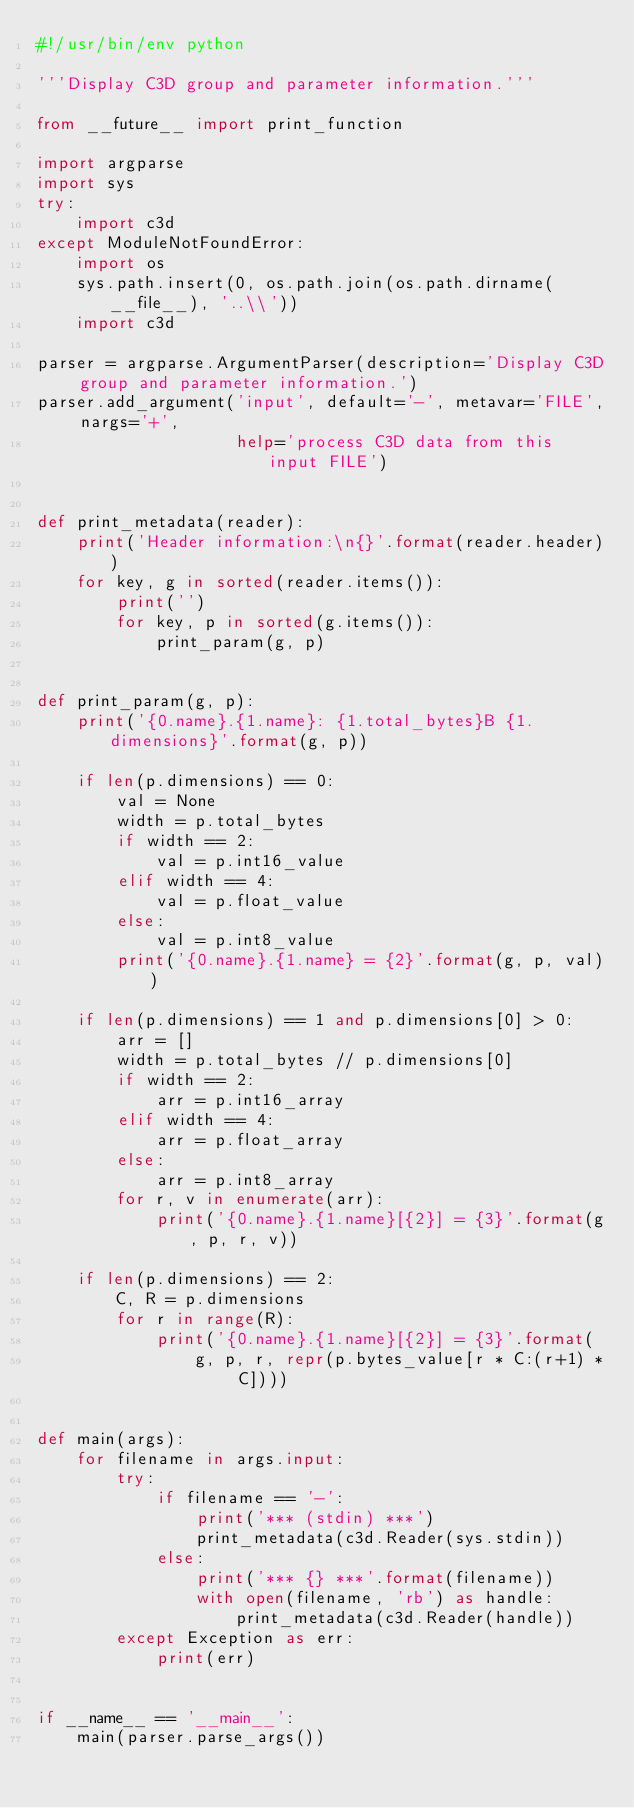Convert code to text. <code><loc_0><loc_0><loc_500><loc_500><_Python_>#!/usr/bin/env python

'''Display C3D group and parameter information.'''

from __future__ import print_function

import argparse
import sys
try:
    import c3d
except ModuleNotFoundError:
    import os
    sys.path.insert(0, os.path.join(os.path.dirname(__file__), '..\\'))
    import c3d

parser = argparse.ArgumentParser(description='Display C3D group and parameter information.')
parser.add_argument('input', default='-', metavar='FILE', nargs='+',
                    help='process C3D data from this input FILE')


def print_metadata(reader):
    print('Header information:\n{}'.format(reader.header))
    for key, g in sorted(reader.items()):
        print('')
        for key, p in sorted(g.items()):
            print_param(g, p)


def print_param(g, p):
    print('{0.name}.{1.name}: {1.total_bytes}B {1.dimensions}'.format(g, p))

    if len(p.dimensions) == 0:
        val = None
        width = p.total_bytes
        if width == 2:
            val = p.int16_value
        elif width == 4:
            val = p.float_value
        else:
            val = p.int8_value
        print('{0.name}.{1.name} = {2}'.format(g, p, val))

    if len(p.dimensions) == 1 and p.dimensions[0] > 0:
        arr = []
        width = p.total_bytes // p.dimensions[0]
        if width == 2:
            arr = p.int16_array
        elif width == 4:
            arr = p.float_array
        else:
            arr = p.int8_array
        for r, v in enumerate(arr):
            print('{0.name}.{1.name}[{2}] = {3}'.format(g, p, r, v))

    if len(p.dimensions) == 2:
        C, R = p.dimensions
        for r in range(R):
            print('{0.name}.{1.name}[{2}] = {3}'.format(
                g, p, r, repr(p.bytes_value[r * C:(r+1) * C])))


def main(args):
    for filename in args.input:
        try:
            if filename == '-':
                print('*** (stdin) ***')
                print_metadata(c3d.Reader(sys.stdin))
            else:
                print('*** {} ***'.format(filename))
                with open(filename, 'rb') as handle:
                    print_metadata(c3d.Reader(handle))
        except Exception as err:
            print(err)


if __name__ == '__main__':
    main(parser.parse_args())
</code> 